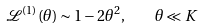<formula> <loc_0><loc_0><loc_500><loc_500>\mathcal { L } ^ { ( 1 ) } ( \theta ) \sim 1 - 2 \theta ^ { 2 } , \quad \theta \ll K</formula> 